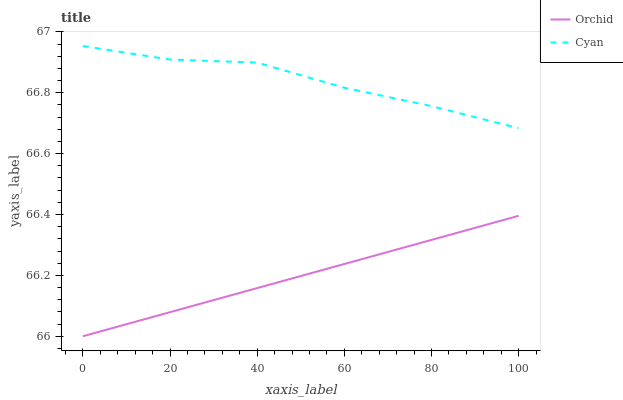Does Orchid have the minimum area under the curve?
Answer yes or no. Yes. Does Cyan have the maximum area under the curve?
Answer yes or no. Yes. Does Orchid have the maximum area under the curve?
Answer yes or no. No. Is Orchid the smoothest?
Answer yes or no. Yes. Is Cyan the roughest?
Answer yes or no. Yes. Is Orchid the roughest?
Answer yes or no. No. Does Orchid have the lowest value?
Answer yes or no. Yes. Does Cyan have the highest value?
Answer yes or no. Yes. Does Orchid have the highest value?
Answer yes or no. No. Is Orchid less than Cyan?
Answer yes or no. Yes. Is Cyan greater than Orchid?
Answer yes or no. Yes. Does Orchid intersect Cyan?
Answer yes or no. No. 